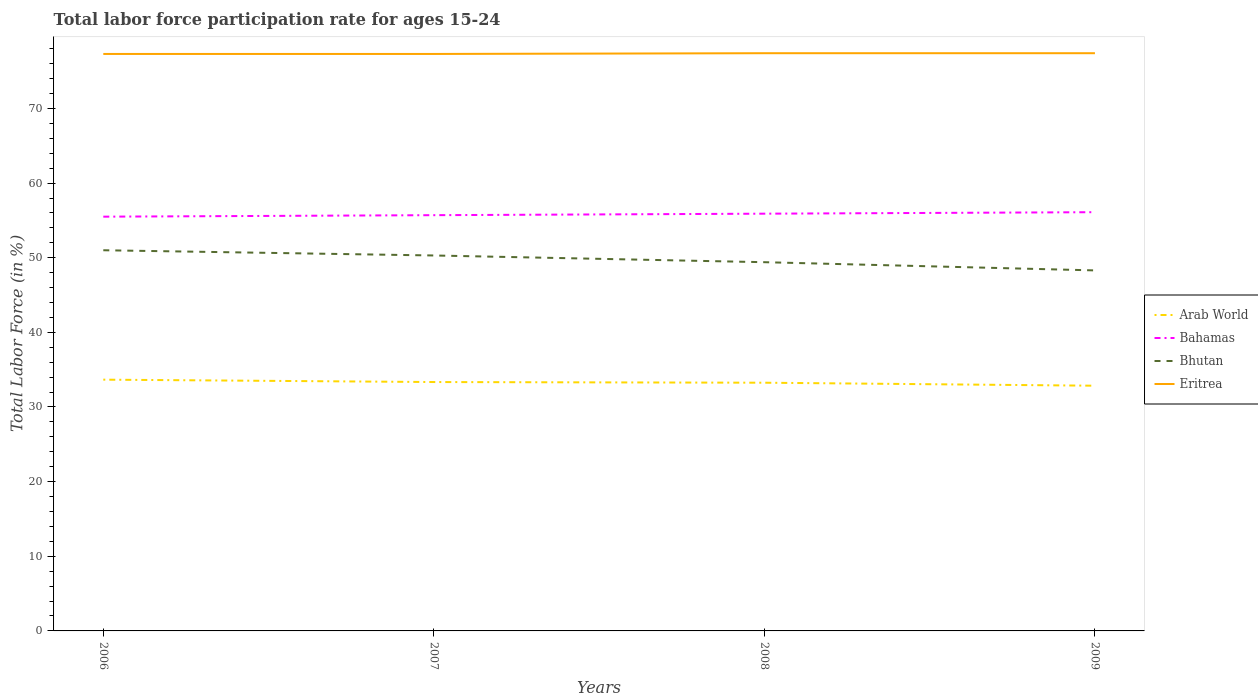Across all years, what is the maximum labor force participation rate in Arab World?
Your answer should be compact. 32.85. In which year was the labor force participation rate in Bhutan maximum?
Offer a terse response. 2009. What is the total labor force participation rate in Bahamas in the graph?
Ensure brevity in your answer.  -0.4. What is the difference between the highest and the second highest labor force participation rate in Bahamas?
Your response must be concise. 0.6. Is the labor force participation rate in Arab World strictly greater than the labor force participation rate in Eritrea over the years?
Offer a very short reply. Yes. Are the values on the major ticks of Y-axis written in scientific E-notation?
Make the answer very short. No. How are the legend labels stacked?
Give a very brief answer. Vertical. What is the title of the graph?
Keep it short and to the point. Total labor force participation rate for ages 15-24. Does "Curacao" appear as one of the legend labels in the graph?
Provide a short and direct response. No. What is the Total Labor Force (in %) of Arab World in 2006?
Provide a succinct answer. 33.66. What is the Total Labor Force (in %) of Bahamas in 2006?
Offer a very short reply. 55.5. What is the Total Labor Force (in %) in Bhutan in 2006?
Ensure brevity in your answer.  51. What is the Total Labor Force (in %) in Eritrea in 2006?
Offer a terse response. 77.3. What is the Total Labor Force (in %) in Arab World in 2007?
Ensure brevity in your answer.  33.34. What is the Total Labor Force (in %) of Bahamas in 2007?
Your answer should be very brief. 55.7. What is the Total Labor Force (in %) in Bhutan in 2007?
Your answer should be very brief. 50.3. What is the Total Labor Force (in %) of Eritrea in 2007?
Make the answer very short. 77.3. What is the Total Labor Force (in %) in Arab World in 2008?
Your response must be concise. 33.25. What is the Total Labor Force (in %) in Bahamas in 2008?
Ensure brevity in your answer.  55.9. What is the Total Labor Force (in %) in Bhutan in 2008?
Give a very brief answer. 49.4. What is the Total Labor Force (in %) of Eritrea in 2008?
Your answer should be very brief. 77.4. What is the Total Labor Force (in %) in Arab World in 2009?
Your answer should be very brief. 32.85. What is the Total Labor Force (in %) of Bahamas in 2009?
Provide a short and direct response. 56.1. What is the Total Labor Force (in %) in Bhutan in 2009?
Offer a terse response. 48.3. What is the Total Labor Force (in %) in Eritrea in 2009?
Offer a very short reply. 77.4. Across all years, what is the maximum Total Labor Force (in %) of Arab World?
Your response must be concise. 33.66. Across all years, what is the maximum Total Labor Force (in %) of Bahamas?
Ensure brevity in your answer.  56.1. Across all years, what is the maximum Total Labor Force (in %) in Bhutan?
Ensure brevity in your answer.  51. Across all years, what is the maximum Total Labor Force (in %) in Eritrea?
Offer a very short reply. 77.4. Across all years, what is the minimum Total Labor Force (in %) of Arab World?
Your answer should be compact. 32.85. Across all years, what is the minimum Total Labor Force (in %) in Bahamas?
Ensure brevity in your answer.  55.5. Across all years, what is the minimum Total Labor Force (in %) of Bhutan?
Keep it short and to the point. 48.3. Across all years, what is the minimum Total Labor Force (in %) of Eritrea?
Ensure brevity in your answer.  77.3. What is the total Total Labor Force (in %) of Arab World in the graph?
Offer a terse response. 133.11. What is the total Total Labor Force (in %) in Bahamas in the graph?
Your response must be concise. 223.2. What is the total Total Labor Force (in %) of Bhutan in the graph?
Ensure brevity in your answer.  199. What is the total Total Labor Force (in %) in Eritrea in the graph?
Your response must be concise. 309.4. What is the difference between the Total Labor Force (in %) in Arab World in 2006 and that in 2007?
Offer a very short reply. 0.32. What is the difference between the Total Labor Force (in %) in Bhutan in 2006 and that in 2007?
Your answer should be very brief. 0.7. What is the difference between the Total Labor Force (in %) of Arab World in 2006 and that in 2008?
Offer a terse response. 0.41. What is the difference between the Total Labor Force (in %) in Bahamas in 2006 and that in 2008?
Give a very brief answer. -0.4. What is the difference between the Total Labor Force (in %) of Arab World in 2006 and that in 2009?
Provide a succinct answer. 0.81. What is the difference between the Total Labor Force (in %) in Bhutan in 2006 and that in 2009?
Give a very brief answer. 2.7. What is the difference between the Total Labor Force (in %) of Eritrea in 2006 and that in 2009?
Give a very brief answer. -0.1. What is the difference between the Total Labor Force (in %) in Arab World in 2007 and that in 2008?
Make the answer very short. 0.09. What is the difference between the Total Labor Force (in %) in Bhutan in 2007 and that in 2008?
Keep it short and to the point. 0.9. What is the difference between the Total Labor Force (in %) of Arab World in 2007 and that in 2009?
Your answer should be very brief. 0.49. What is the difference between the Total Labor Force (in %) of Bhutan in 2007 and that in 2009?
Make the answer very short. 2. What is the difference between the Total Labor Force (in %) of Arab World in 2008 and that in 2009?
Ensure brevity in your answer.  0.4. What is the difference between the Total Labor Force (in %) in Eritrea in 2008 and that in 2009?
Provide a short and direct response. 0. What is the difference between the Total Labor Force (in %) of Arab World in 2006 and the Total Labor Force (in %) of Bahamas in 2007?
Your answer should be very brief. -22.04. What is the difference between the Total Labor Force (in %) of Arab World in 2006 and the Total Labor Force (in %) of Bhutan in 2007?
Offer a very short reply. -16.64. What is the difference between the Total Labor Force (in %) in Arab World in 2006 and the Total Labor Force (in %) in Eritrea in 2007?
Provide a short and direct response. -43.64. What is the difference between the Total Labor Force (in %) of Bahamas in 2006 and the Total Labor Force (in %) of Eritrea in 2007?
Your answer should be compact. -21.8. What is the difference between the Total Labor Force (in %) of Bhutan in 2006 and the Total Labor Force (in %) of Eritrea in 2007?
Offer a terse response. -26.3. What is the difference between the Total Labor Force (in %) of Arab World in 2006 and the Total Labor Force (in %) of Bahamas in 2008?
Offer a very short reply. -22.24. What is the difference between the Total Labor Force (in %) of Arab World in 2006 and the Total Labor Force (in %) of Bhutan in 2008?
Keep it short and to the point. -15.74. What is the difference between the Total Labor Force (in %) in Arab World in 2006 and the Total Labor Force (in %) in Eritrea in 2008?
Keep it short and to the point. -43.74. What is the difference between the Total Labor Force (in %) of Bahamas in 2006 and the Total Labor Force (in %) of Bhutan in 2008?
Provide a succinct answer. 6.1. What is the difference between the Total Labor Force (in %) in Bahamas in 2006 and the Total Labor Force (in %) in Eritrea in 2008?
Ensure brevity in your answer.  -21.9. What is the difference between the Total Labor Force (in %) of Bhutan in 2006 and the Total Labor Force (in %) of Eritrea in 2008?
Provide a short and direct response. -26.4. What is the difference between the Total Labor Force (in %) of Arab World in 2006 and the Total Labor Force (in %) of Bahamas in 2009?
Keep it short and to the point. -22.44. What is the difference between the Total Labor Force (in %) of Arab World in 2006 and the Total Labor Force (in %) of Bhutan in 2009?
Your answer should be very brief. -14.64. What is the difference between the Total Labor Force (in %) of Arab World in 2006 and the Total Labor Force (in %) of Eritrea in 2009?
Your answer should be very brief. -43.74. What is the difference between the Total Labor Force (in %) of Bahamas in 2006 and the Total Labor Force (in %) of Eritrea in 2009?
Your answer should be compact. -21.9. What is the difference between the Total Labor Force (in %) in Bhutan in 2006 and the Total Labor Force (in %) in Eritrea in 2009?
Provide a short and direct response. -26.4. What is the difference between the Total Labor Force (in %) of Arab World in 2007 and the Total Labor Force (in %) of Bahamas in 2008?
Provide a short and direct response. -22.56. What is the difference between the Total Labor Force (in %) in Arab World in 2007 and the Total Labor Force (in %) in Bhutan in 2008?
Your answer should be compact. -16.06. What is the difference between the Total Labor Force (in %) of Arab World in 2007 and the Total Labor Force (in %) of Eritrea in 2008?
Your response must be concise. -44.06. What is the difference between the Total Labor Force (in %) of Bahamas in 2007 and the Total Labor Force (in %) of Bhutan in 2008?
Your answer should be very brief. 6.3. What is the difference between the Total Labor Force (in %) in Bahamas in 2007 and the Total Labor Force (in %) in Eritrea in 2008?
Make the answer very short. -21.7. What is the difference between the Total Labor Force (in %) of Bhutan in 2007 and the Total Labor Force (in %) of Eritrea in 2008?
Your answer should be very brief. -27.1. What is the difference between the Total Labor Force (in %) in Arab World in 2007 and the Total Labor Force (in %) in Bahamas in 2009?
Keep it short and to the point. -22.76. What is the difference between the Total Labor Force (in %) of Arab World in 2007 and the Total Labor Force (in %) of Bhutan in 2009?
Your response must be concise. -14.96. What is the difference between the Total Labor Force (in %) in Arab World in 2007 and the Total Labor Force (in %) in Eritrea in 2009?
Your response must be concise. -44.06. What is the difference between the Total Labor Force (in %) of Bahamas in 2007 and the Total Labor Force (in %) of Eritrea in 2009?
Your response must be concise. -21.7. What is the difference between the Total Labor Force (in %) of Bhutan in 2007 and the Total Labor Force (in %) of Eritrea in 2009?
Give a very brief answer. -27.1. What is the difference between the Total Labor Force (in %) in Arab World in 2008 and the Total Labor Force (in %) in Bahamas in 2009?
Give a very brief answer. -22.85. What is the difference between the Total Labor Force (in %) of Arab World in 2008 and the Total Labor Force (in %) of Bhutan in 2009?
Your answer should be very brief. -15.05. What is the difference between the Total Labor Force (in %) in Arab World in 2008 and the Total Labor Force (in %) in Eritrea in 2009?
Your answer should be compact. -44.15. What is the difference between the Total Labor Force (in %) of Bahamas in 2008 and the Total Labor Force (in %) of Bhutan in 2009?
Keep it short and to the point. 7.6. What is the difference between the Total Labor Force (in %) of Bahamas in 2008 and the Total Labor Force (in %) of Eritrea in 2009?
Your answer should be compact. -21.5. What is the average Total Labor Force (in %) of Arab World per year?
Make the answer very short. 33.28. What is the average Total Labor Force (in %) of Bahamas per year?
Give a very brief answer. 55.8. What is the average Total Labor Force (in %) in Bhutan per year?
Your answer should be very brief. 49.75. What is the average Total Labor Force (in %) of Eritrea per year?
Provide a succinct answer. 77.35. In the year 2006, what is the difference between the Total Labor Force (in %) in Arab World and Total Labor Force (in %) in Bahamas?
Your response must be concise. -21.84. In the year 2006, what is the difference between the Total Labor Force (in %) in Arab World and Total Labor Force (in %) in Bhutan?
Provide a short and direct response. -17.34. In the year 2006, what is the difference between the Total Labor Force (in %) in Arab World and Total Labor Force (in %) in Eritrea?
Your answer should be very brief. -43.64. In the year 2006, what is the difference between the Total Labor Force (in %) in Bahamas and Total Labor Force (in %) in Bhutan?
Offer a very short reply. 4.5. In the year 2006, what is the difference between the Total Labor Force (in %) of Bahamas and Total Labor Force (in %) of Eritrea?
Provide a short and direct response. -21.8. In the year 2006, what is the difference between the Total Labor Force (in %) in Bhutan and Total Labor Force (in %) in Eritrea?
Offer a terse response. -26.3. In the year 2007, what is the difference between the Total Labor Force (in %) of Arab World and Total Labor Force (in %) of Bahamas?
Provide a short and direct response. -22.36. In the year 2007, what is the difference between the Total Labor Force (in %) in Arab World and Total Labor Force (in %) in Bhutan?
Offer a very short reply. -16.96. In the year 2007, what is the difference between the Total Labor Force (in %) of Arab World and Total Labor Force (in %) of Eritrea?
Provide a short and direct response. -43.96. In the year 2007, what is the difference between the Total Labor Force (in %) of Bahamas and Total Labor Force (in %) of Bhutan?
Offer a terse response. 5.4. In the year 2007, what is the difference between the Total Labor Force (in %) of Bahamas and Total Labor Force (in %) of Eritrea?
Your answer should be very brief. -21.6. In the year 2007, what is the difference between the Total Labor Force (in %) in Bhutan and Total Labor Force (in %) in Eritrea?
Your answer should be very brief. -27. In the year 2008, what is the difference between the Total Labor Force (in %) in Arab World and Total Labor Force (in %) in Bahamas?
Offer a terse response. -22.65. In the year 2008, what is the difference between the Total Labor Force (in %) of Arab World and Total Labor Force (in %) of Bhutan?
Offer a terse response. -16.15. In the year 2008, what is the difference between the Total Labor Force (in %) of Arab World and Total Labor Force (in %) of Eritrea?
Your answer should be compact. -44.15. In the year 2008, what is the difference between the Total Labor Force (in %) of Bahamas and Total Labor Force (in %) of Eritrea?
Provide a short and direct response. -21.5. In the year 2009, what is the difference between the Total Labor Force (in %) in Arab World and Total Labor Force (in %) in Bahamas?
Provide a succinct answer. -23.25. In the year 2009, what is the difference between the Total Labor Force (in %) of Arab World and Total Labor Force (in %) of Bhutan?
Your response must be concise. -15.45. In the year 2009, what is the difference between the Total Labor Force (in %) of Arab World and Total Labor Force (in %) of Eritrea?
Your answer should be compact. -44.55. In the year 2009, what is the difference between the Total Labor Force (in %) of Bahamas and Total Labor Force (in %) of Bhutan?
Provide a succinct answer. 7.8. In the year 2009, what is the difference between the Total Labor Force (in %) of Bahamas and Total Labor Force (in %) of Eritrea?
Make the answer very short. -21.3. In the year 2009, what is the difference between the Total Labor Force (in %) of Bhutan and Total Labor Force (in %) of Eritrea?
Provide a short and direct response. -29.1. What is the ratio of the Total Labor Force (in %) of Arab World in 2006 to that in 2007?
Offer a terse response. 1.01. What is the ratio of the Total Labor Force (in %) in Bahamas in 2006 to that in 2007?
Provide a short and direct response. 1. What is the ratio of the Total Labor Force (in %) in Bhutan in 2006 to that in 2007?
Provide a short and direct response. 1.01. What is the ratio of the Total Labor Force (in %) in Arab World in 2006 to that in 2008?
Provide a succinct answer. 1.01. What is the ratio of the Total Labor Force (in %) in Bhutan in 2006 to that in 2008?
Your answer should be very brief. 1.03. What is the ratio of the Total Labor Force (in %) in Eritrea in 2006 to that in 2008?
Provide a short and direct response. 1. What is the ratio of the Total Labor Force (in %) of Arab World in 2006 to that in 2009?
Offer a terse response. 1.02. What is the ratio of the Total Labor Force (in %) of Bahamas in 2006 to that in 2009?
Your answer should be compact. 0.99. What is the ratio of the Total Labor Force (in %) in Bhutan in 2006 to that in 2009?
Keep it short and to the point. 1.06. What is the ratio of the Total Labor Force (in %) in Bahamas in 2007 to that in 2008?
Your answer should be compact. 1. What is the ratio of the Total Labor Force (in %) of Bhutan in 2007 to that in 2008?
Provide a short and direct response. 1.02. What is the ratio of the Total Labor Force (in %) of Eritrea in 2007 to that in 2008?
Ensure brevity in your answer.  1. What is the ratio of the Total Labor Force (in %) in Bhutan in 2007 to that in 2009?
Your answer should be very brief. 1.04. What is the ratio of the Total Labor Force (in %) of Arab World in 2008 to that in 2009?
Your answer should be compact. 1.01. What is the ratio of the Total Labor Force (in %) in Bahamas in 2008 to that in 2009?
Ensure brevity in your answer.  1. What is the ratio of the Total Labor Force (in %) of Bhutan in 2008 to that in 2009?
Your answer should be compact. 1.02. What is the ratio of the Total Labor Force (in %) in Eritrea in 2008 to that in 2009?
Provide a short and direct response. 1. What is the difference between the highest and the second highest Total Labor Force (in %) of Arab World?
Your answer should be very brief. 0.32. What is the difference between the highest and the second highest Total Labor Force (in %) in Eritrea?
Provide a short and direct response. 0. What is the difference between the highest and the lowest Total Labor Force (in %) of Arab World?
Offer a terse response. 0.81. What is the difference between the highest and the lowest Total Labor Force (in %) in Bhutan?
Offer a terse response. 2.7. 